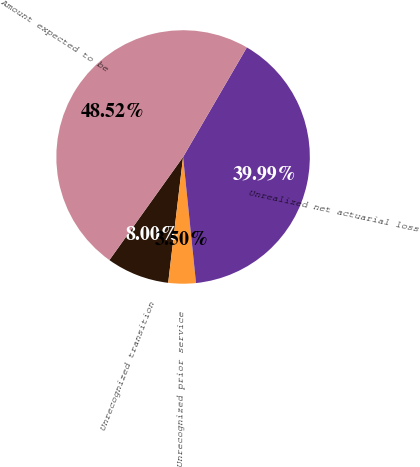Convert chart. <chart><loc_0><loc_0><loc_500><loc_500><pie_chart><fcel>Unrecognized transition<fcel>Unrecognized prior service<fcel>Unrealized net actuarial loss<fcel>Amount expected to be<nl><fcel>8.0%<fcel>3.5%<fcel>39.99%<fcel>48.52%<nl></chart> 